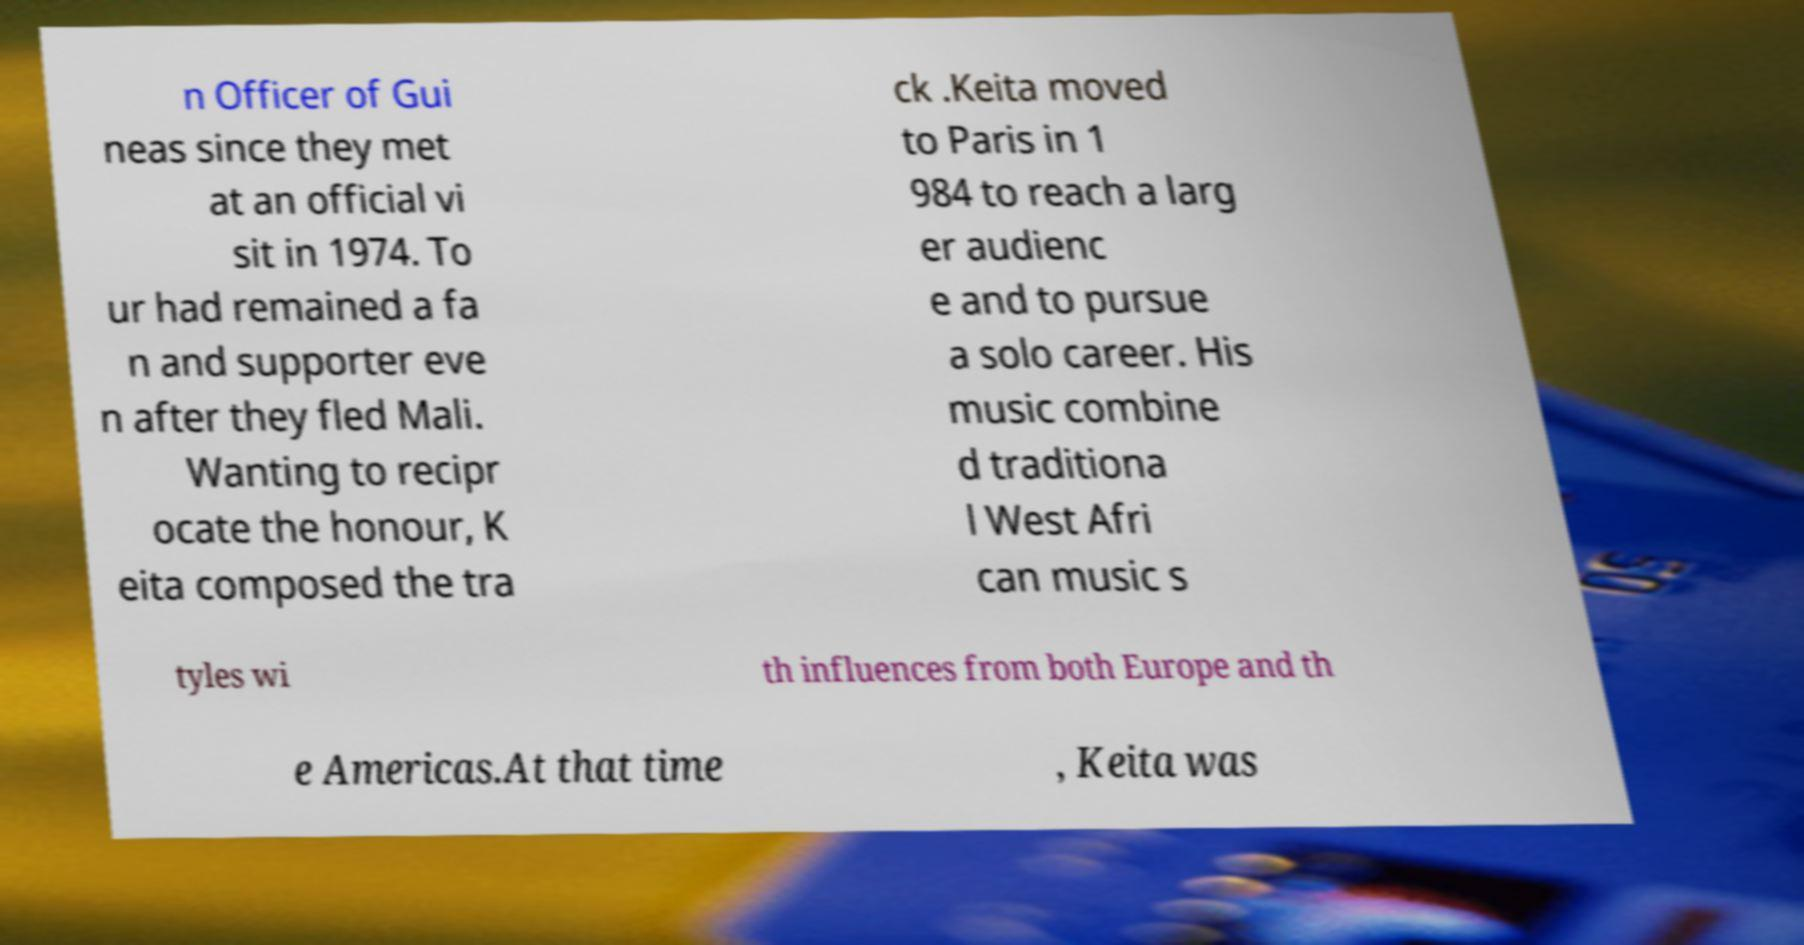Can you read and provide the text displayed in the image?This photo seems to have some interesting text. Can you extract and type it out for me? n Officer of Gui neas since they met at an official vi sit in 1974. To ur had remained a fa n and supporter eve n after they fled Mali. Wanting to recipr ocate the honour, K eita composed the tra ck .Keita moved to Paris in 1 984 to reach a larg er audienc e and to pursue a solo career. His music combine d traditiona l West Afri can music s tyles wi th influences from both Europe and th e Americas.At that time , Keita was 